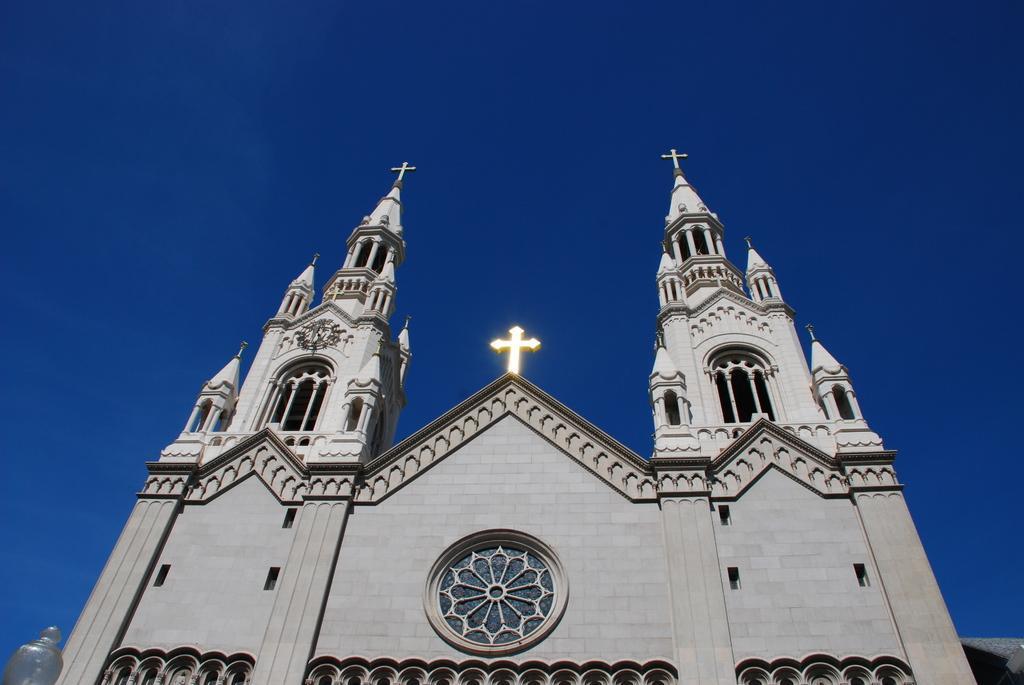How would you summarize this image in a sentence or two? Here in this picture we can see a church building present over a place and at the top of it we can see Christianity symbols present and we can see the sky is clear. 